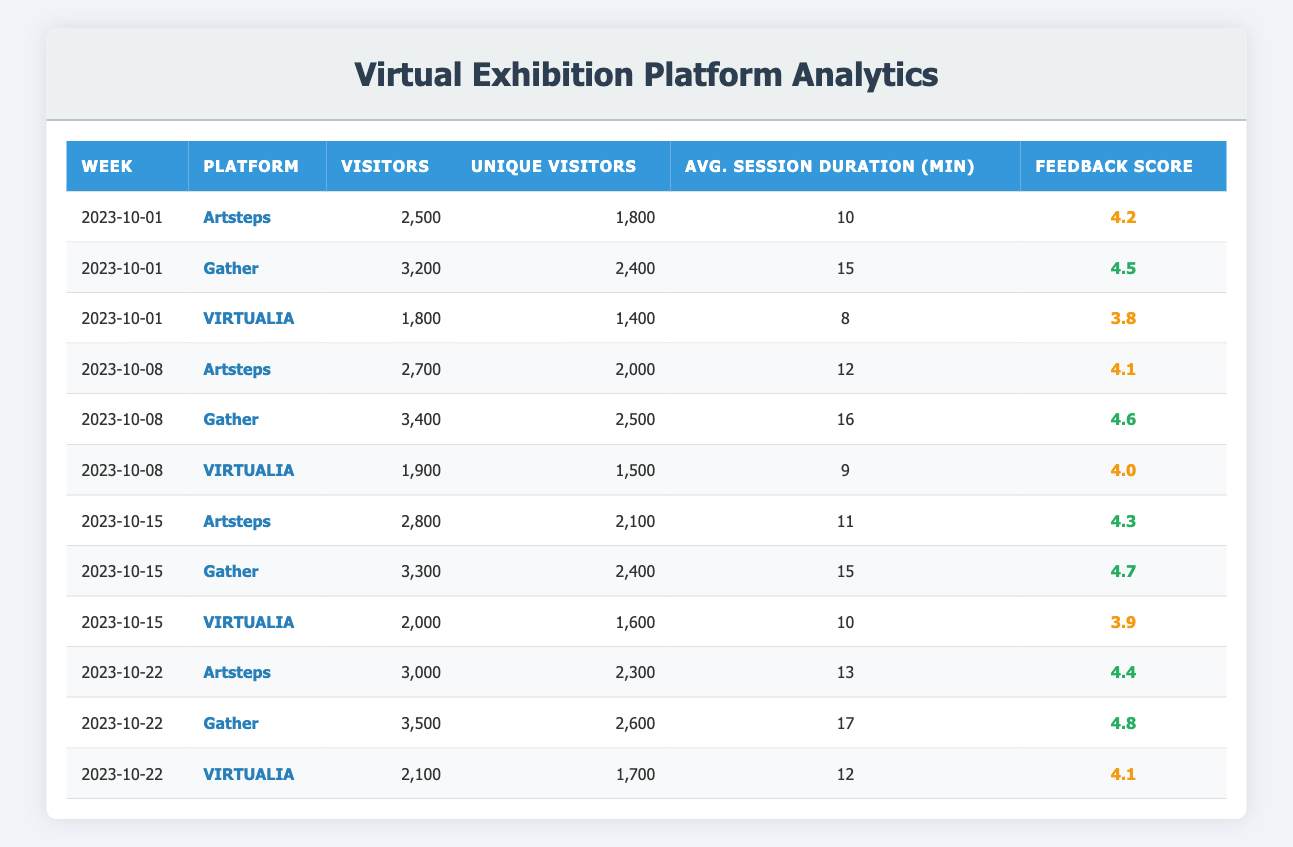What platform had the highest number of visitors on 2023-10-22? Referring to the table for the week of 2023-10-22, "Gather" had 3,500 visitors, which is the highest compared to "Artsteps" (3,000) and "VIRTUALIA" (2,100).
Answer: Gather What was the average session duration for the "VIRTUALIA" platform over the four weeks? For "VIRTUALIA," the session durations for the four weeks are 8, 9, 10, and 12 minutes. Adding these gives 8 + 9 + 10 + 12 = 39 minutes. Dividing by 4 (the number of weeks), the average session duration is 39 / 4 = 9.75 minutes.
Answer: 9.75 minutes Which platform received a feedback score of 4.7 or higher on any week? Upon reviewing the feedback scores, "Gather" had scores of 4.5, 4.6, and 4.7 in different weeks, all above 4.7. "Artsteps" scored 4.1, 4.3, and 4.4, which do not reach 4.7, and "VIRTUALIA" scored below that threshold.
Answer: Yes How many unique visitors did “Artsteps” have in total over the four weeks? The unique visitors for "Artsteps" over the four weeks are 1,800 (2023-10-01), 2,000 (2023-10-08), 2,100 (2023-10-15), and 2,300 (2023-10-22). Summing these gives 1,800 + 2,000 + 2,100 + 2,300 = 8,200 unique visitors total.
Answer: 8,200 unique visitors Did the average feedback score for "Gather" increase from week to week? The feedback scores for "Gather" over the four weeks are 4.5 (2023-10-01), 4.6 (2023-10-08), 4.7 (2023-10-15), and 4.8 (2023-10-22). As each subsequent score is higher than the previous, this confirms it increased consistently.
Answer: Yes What is the difference in visitors between "Gather" and "VIRTUALIA" during the week of 2023-10-15? On 2023-10-15, "Gather" had 3,300 visitors while "VIRTUALIA" had 2,000 visitors. The difference is 3,300 - 2,000 = 1,300 visitors more for "Gather."
Answer: 1,300 visitors What percentage of visitors for "Artsteps" in week 2023-10-08 were unique visitors? In week 2023-10-08, "Artsteps" had 2,700 visitors and 2,000 unique visitors. The percentage is calculated as (2,000 / 2,700) * 100 = approximately 74.07%.
Answer: 74.07% What was the highest feedback score among the three platforms at any time during the observed period? By checking all feedback scores—4.5 (Gather), 4.6 (Gather), 4.7 (Gather), and 4.8 (Gather) found in week 2023-10-22—the highest score is 4.8.
Answer: 4.8 Which platform showed the least number of visitors on 2023-10-01? According to the table, on 2023-10-01, "VIRTUALIA" had 1,800 visitors, which is less than both "Artsteps" (2,500) and "Gather" (3,200).
Answer: VIRTUALIA What is the trend of average session duration across all platforms from 2023-10-01 to 2023-10-22? For each week, the average session durations for "Artsteps," "Gather," and "VIRTUALIA" are: 10, 15, 8; 12, 16, 9; 11, 15, 10; and 13, 17, 12 respectively. Looking at these values, we see a slight increase in average session duration for most platforms over the four weeks, particularly for "Gather" and "Artsteps."
Answer: Increasing trend 